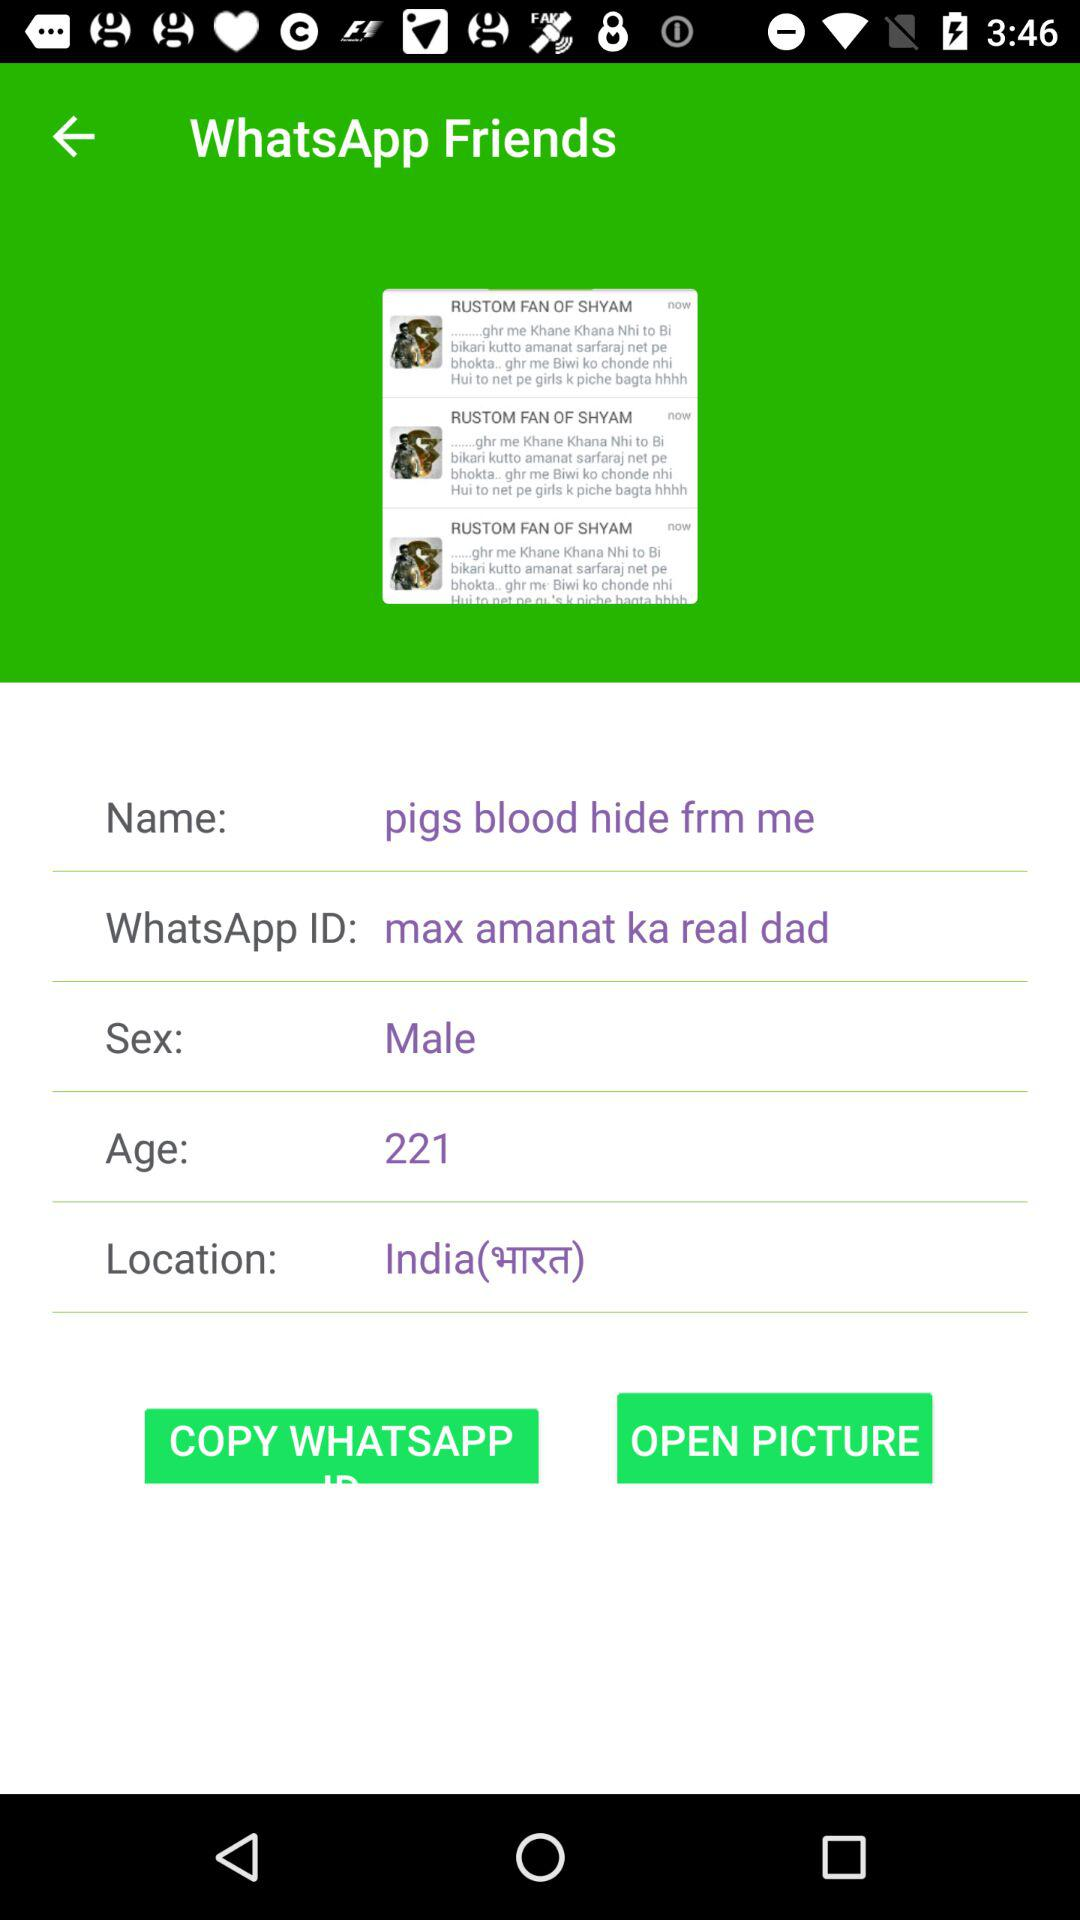What is the "WhatsApp" ID? The "WhatsApp" ID is "max amanat ka real dad". 